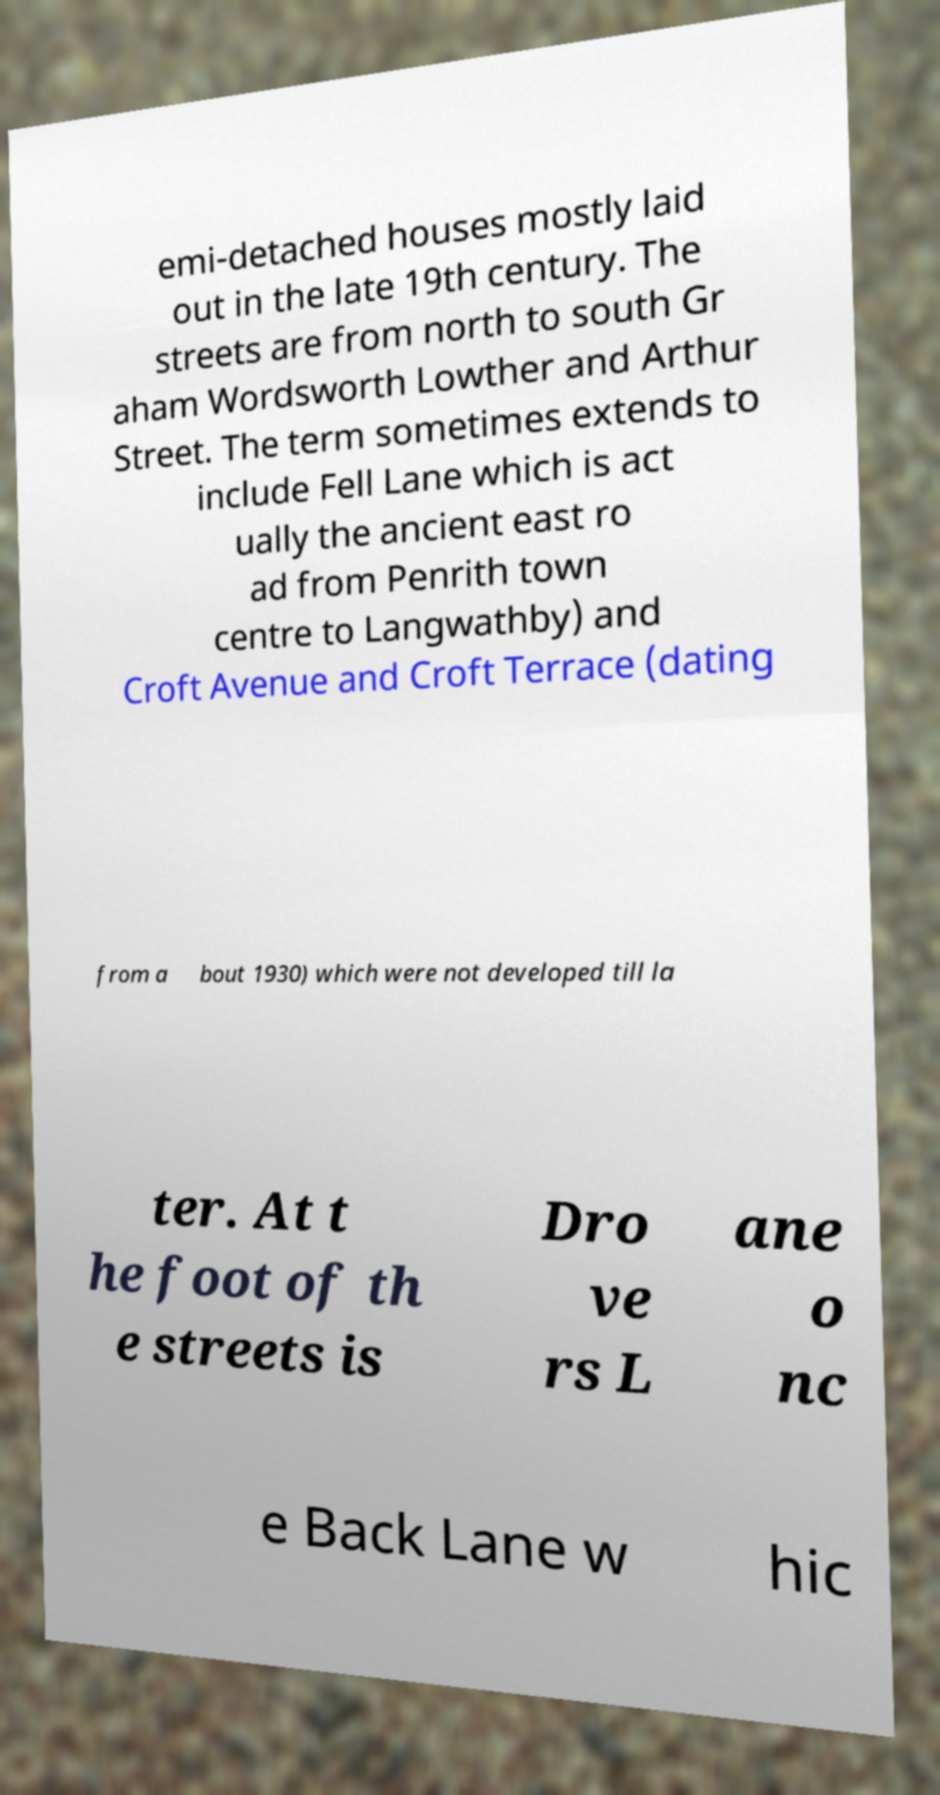Please identify and transcribe the text found in this image. emi-detached houses mostly laid out in the late 19th century. The streets are from north to south Gr aham Wordsworth Lowther and Arthur Street. The term sometimes extends to include Fell Lane which is act ually the ancient east ro ad from Penrith town centre to Langwathby) and Croft Avenue and Croft Terrace (dating from a bout 1930) which were not developed till la ter. At t he foot of th e streets is Dro ve rs L ane o nc e Back Lane w hic 